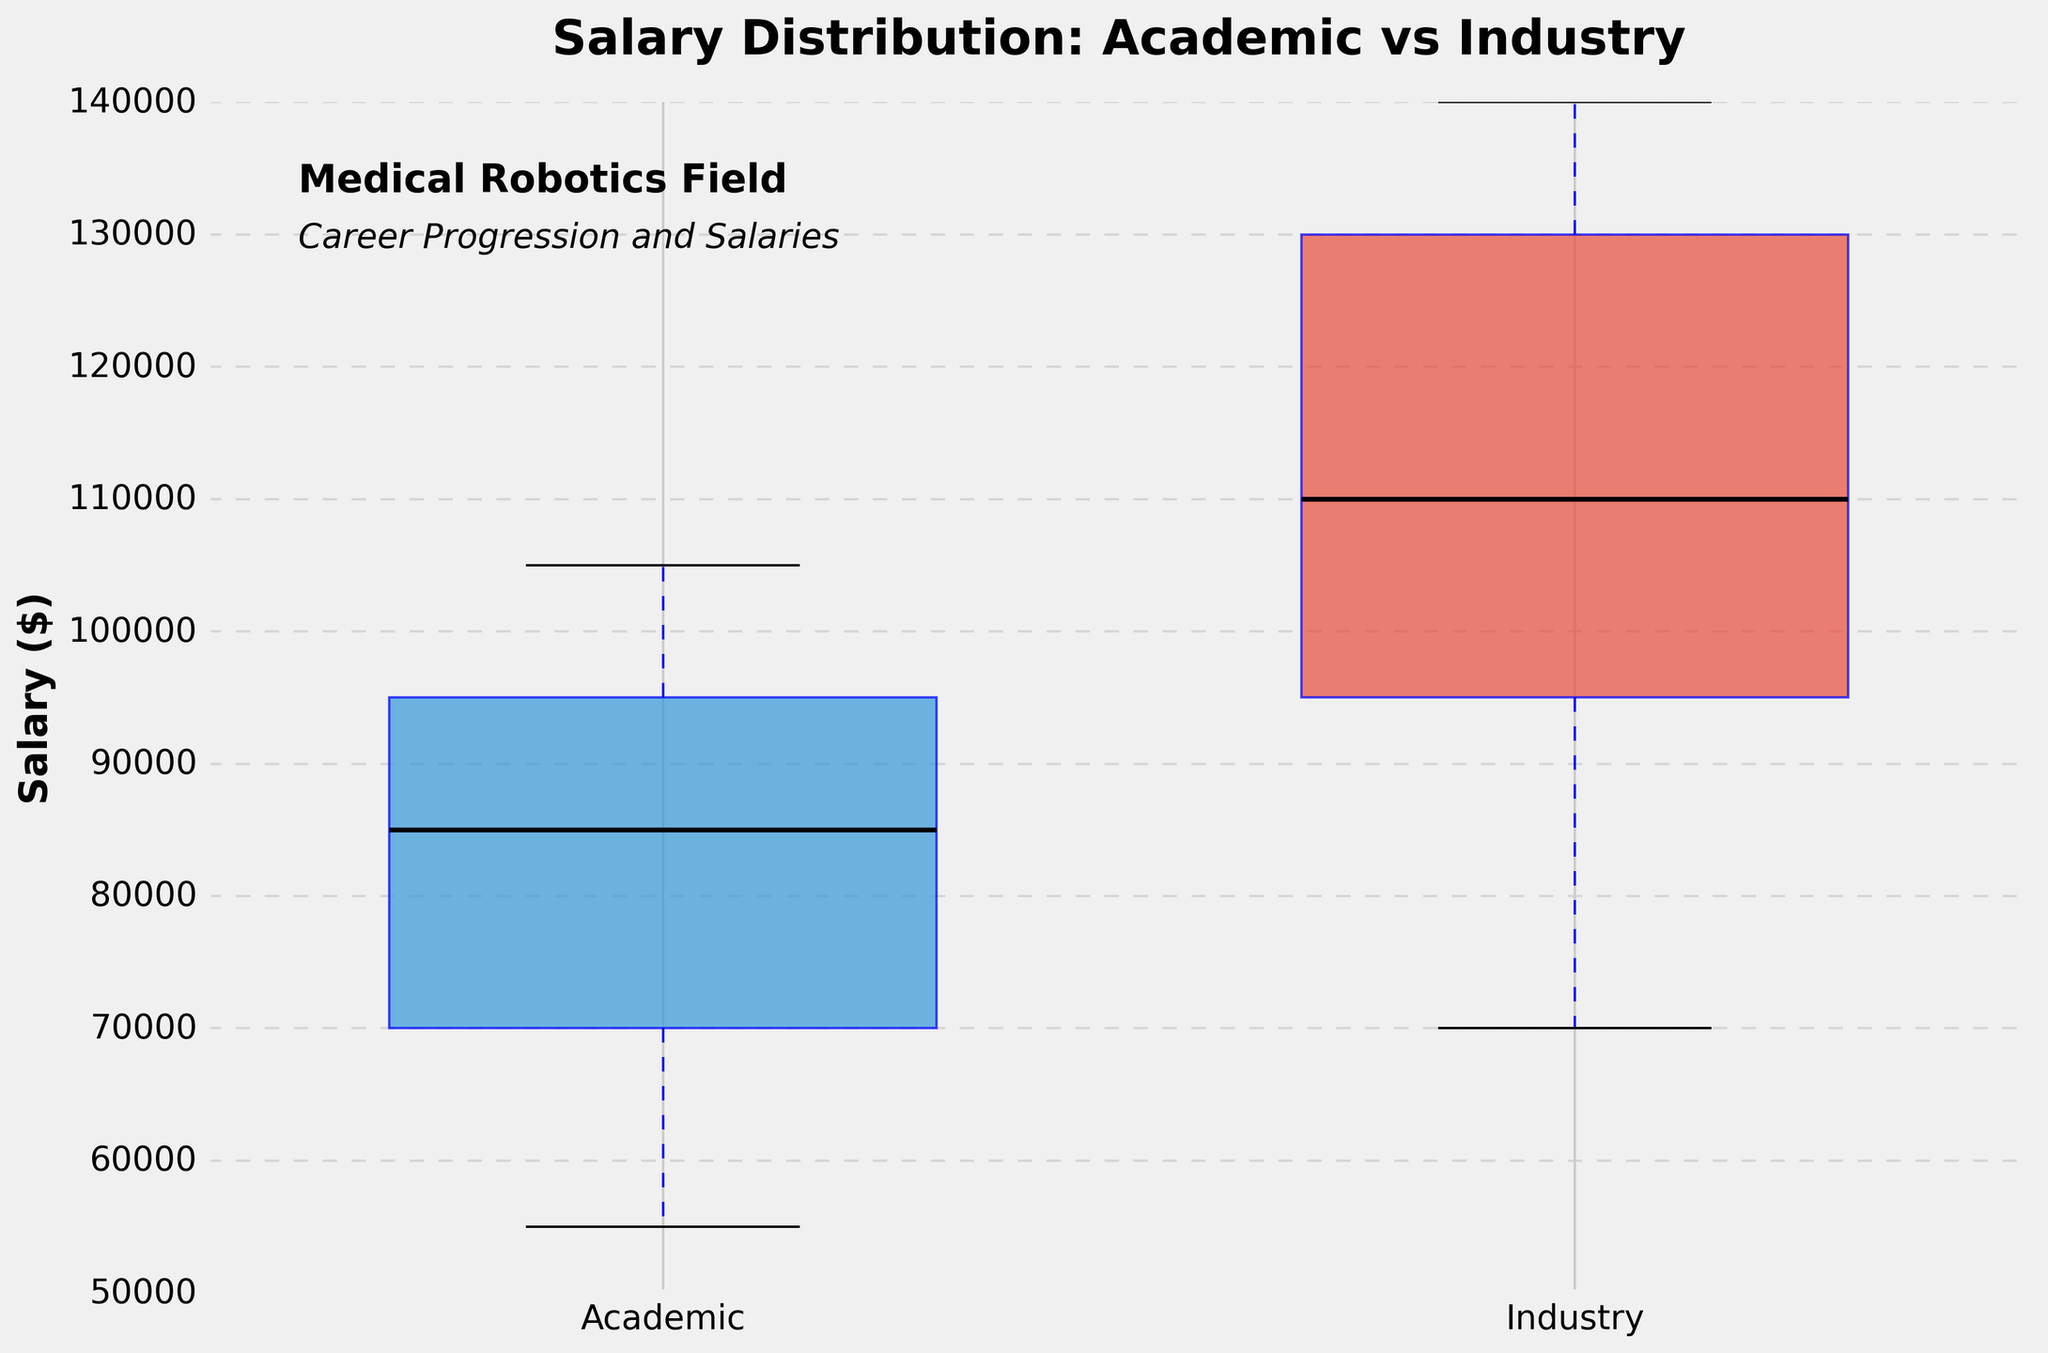What are the titles of the x-axis and y-axis? The x-axis title comes from the labels on the box plots representing the two groups: 'Academic' and 'Industry'. The y-axis title is provided explicitly in the plot, labeled as 'Salary ($)'.
Answer: x-axis: 'Academic' and 'Industry', y-axis: 'Salary ($)' What is the median salary for the Industry group? The median salary in the Industry group is represented by the line inside the Industry box, which is colored black. According to the visual, the median line of the Industry box is at $110,000.
Answer: $110,000 How do the salary ranges (min and max) differ between the Academic and Industry groups? The salary range in the Academic group is from the bottom of the whisker (approximately $54,000) to the top whisker (approximately $106,000). In the Industry group, the salary range is from the bottom of the whisker (approximately $69,000) to the top whisker (approximately $141,000). The Industry group has a higher range.
Answer: Academic: $54,000 to $106,000; Industry: $69,000 to $141,000 Which group shows a higher variability in salary? Variability is showcased by the length of the whiskers and the interquartile range (the height of the box). The Industry group has longer whiskers and a taller box compared to the Academic group, indicating higher variability.
Answer: Industry What is the interquartile range (IQR) for the Academic group? The IQR is the range between the first quartile (bottom of the Academic box) and the third quartile (top of the Academic box). From the plot, the bottom of the box is around $70,000, and the top of the box is around $95,000. So, IQR = $95,000 - $70,000 = $25,000.
Answer: $25,000 How do the medians compare between the two groups? Compare the black median lines inside each box. The median for Academic is around $80,000, while for Industry, it is around $110,000. Industry's median is higher than Academic's median.
Answer: Industry > Academic Are there any outliers in either group? Outliers are typically represented by points outside the whiskers in a box plot. There are no distinct points beyond the whiskers in either group, suggesting no outliers.
Answer: None What can be inferred about the spread of the salaries in the Academic group compared to the Industry group? The Academic group's box plot has shorter whiskers and a smaller interquartile range than the Industry group, indicating a tighter spread. In contrast, the Industry group shows larger spread with higher maximum salaries and more dispersed data.
Answer: Academic has a tighter spread; Industry has a larger spread What is the overall trend in salaries between the two groups? The plot shows that the Industry group has both higher median salaries and a larger range of salaries compared to the Academic group, suggesting that individuals in Industry generally earn more and salaries are more variable.
Answer: Industry generally earns more 